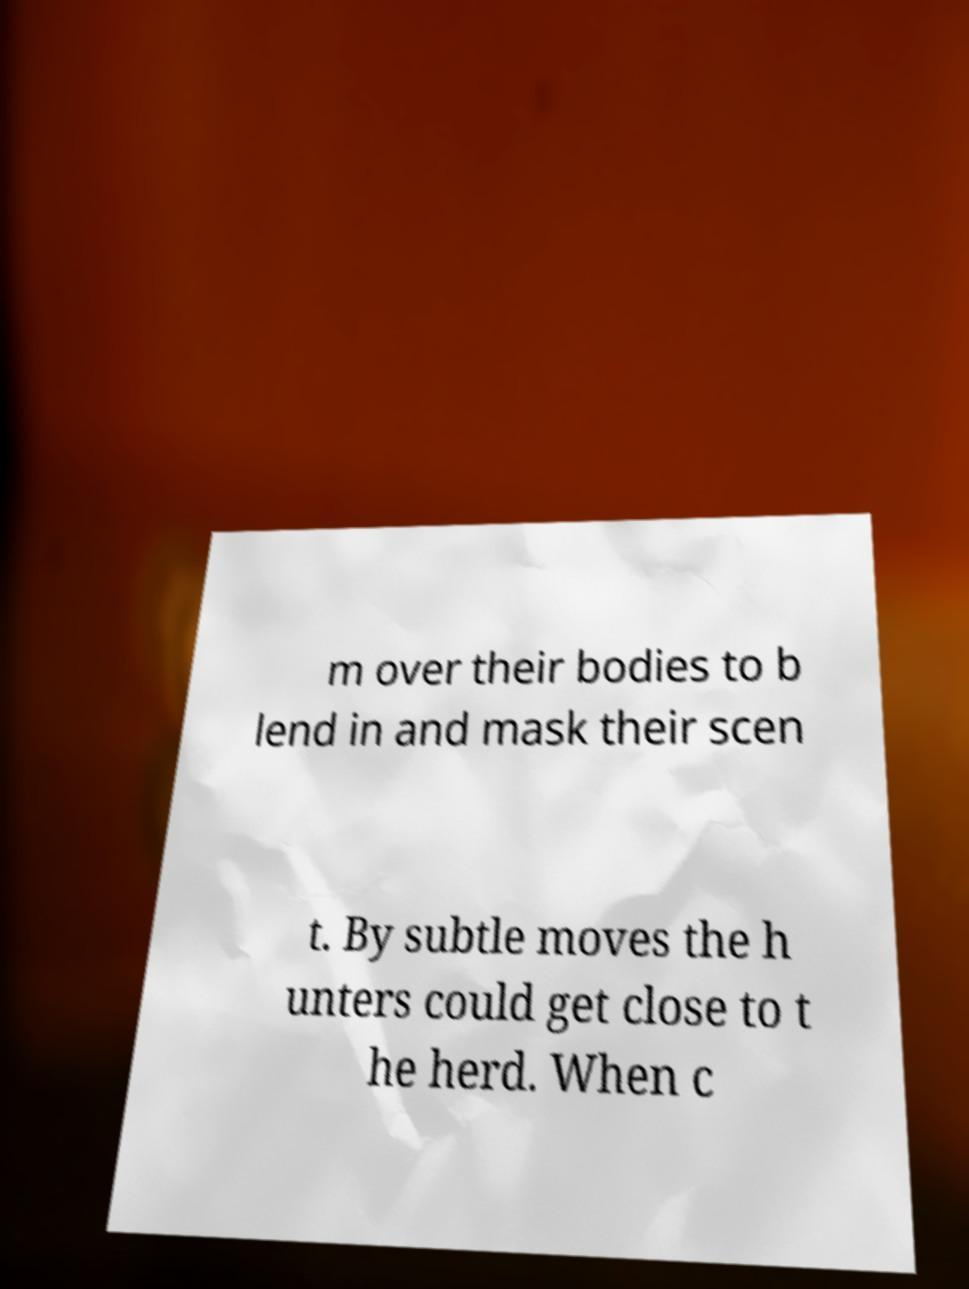Could you extract and type out the text from this image? m over their bodies to b lend in and mask their scen t. By subtle moves the h unters could get close to t he herd. When c 